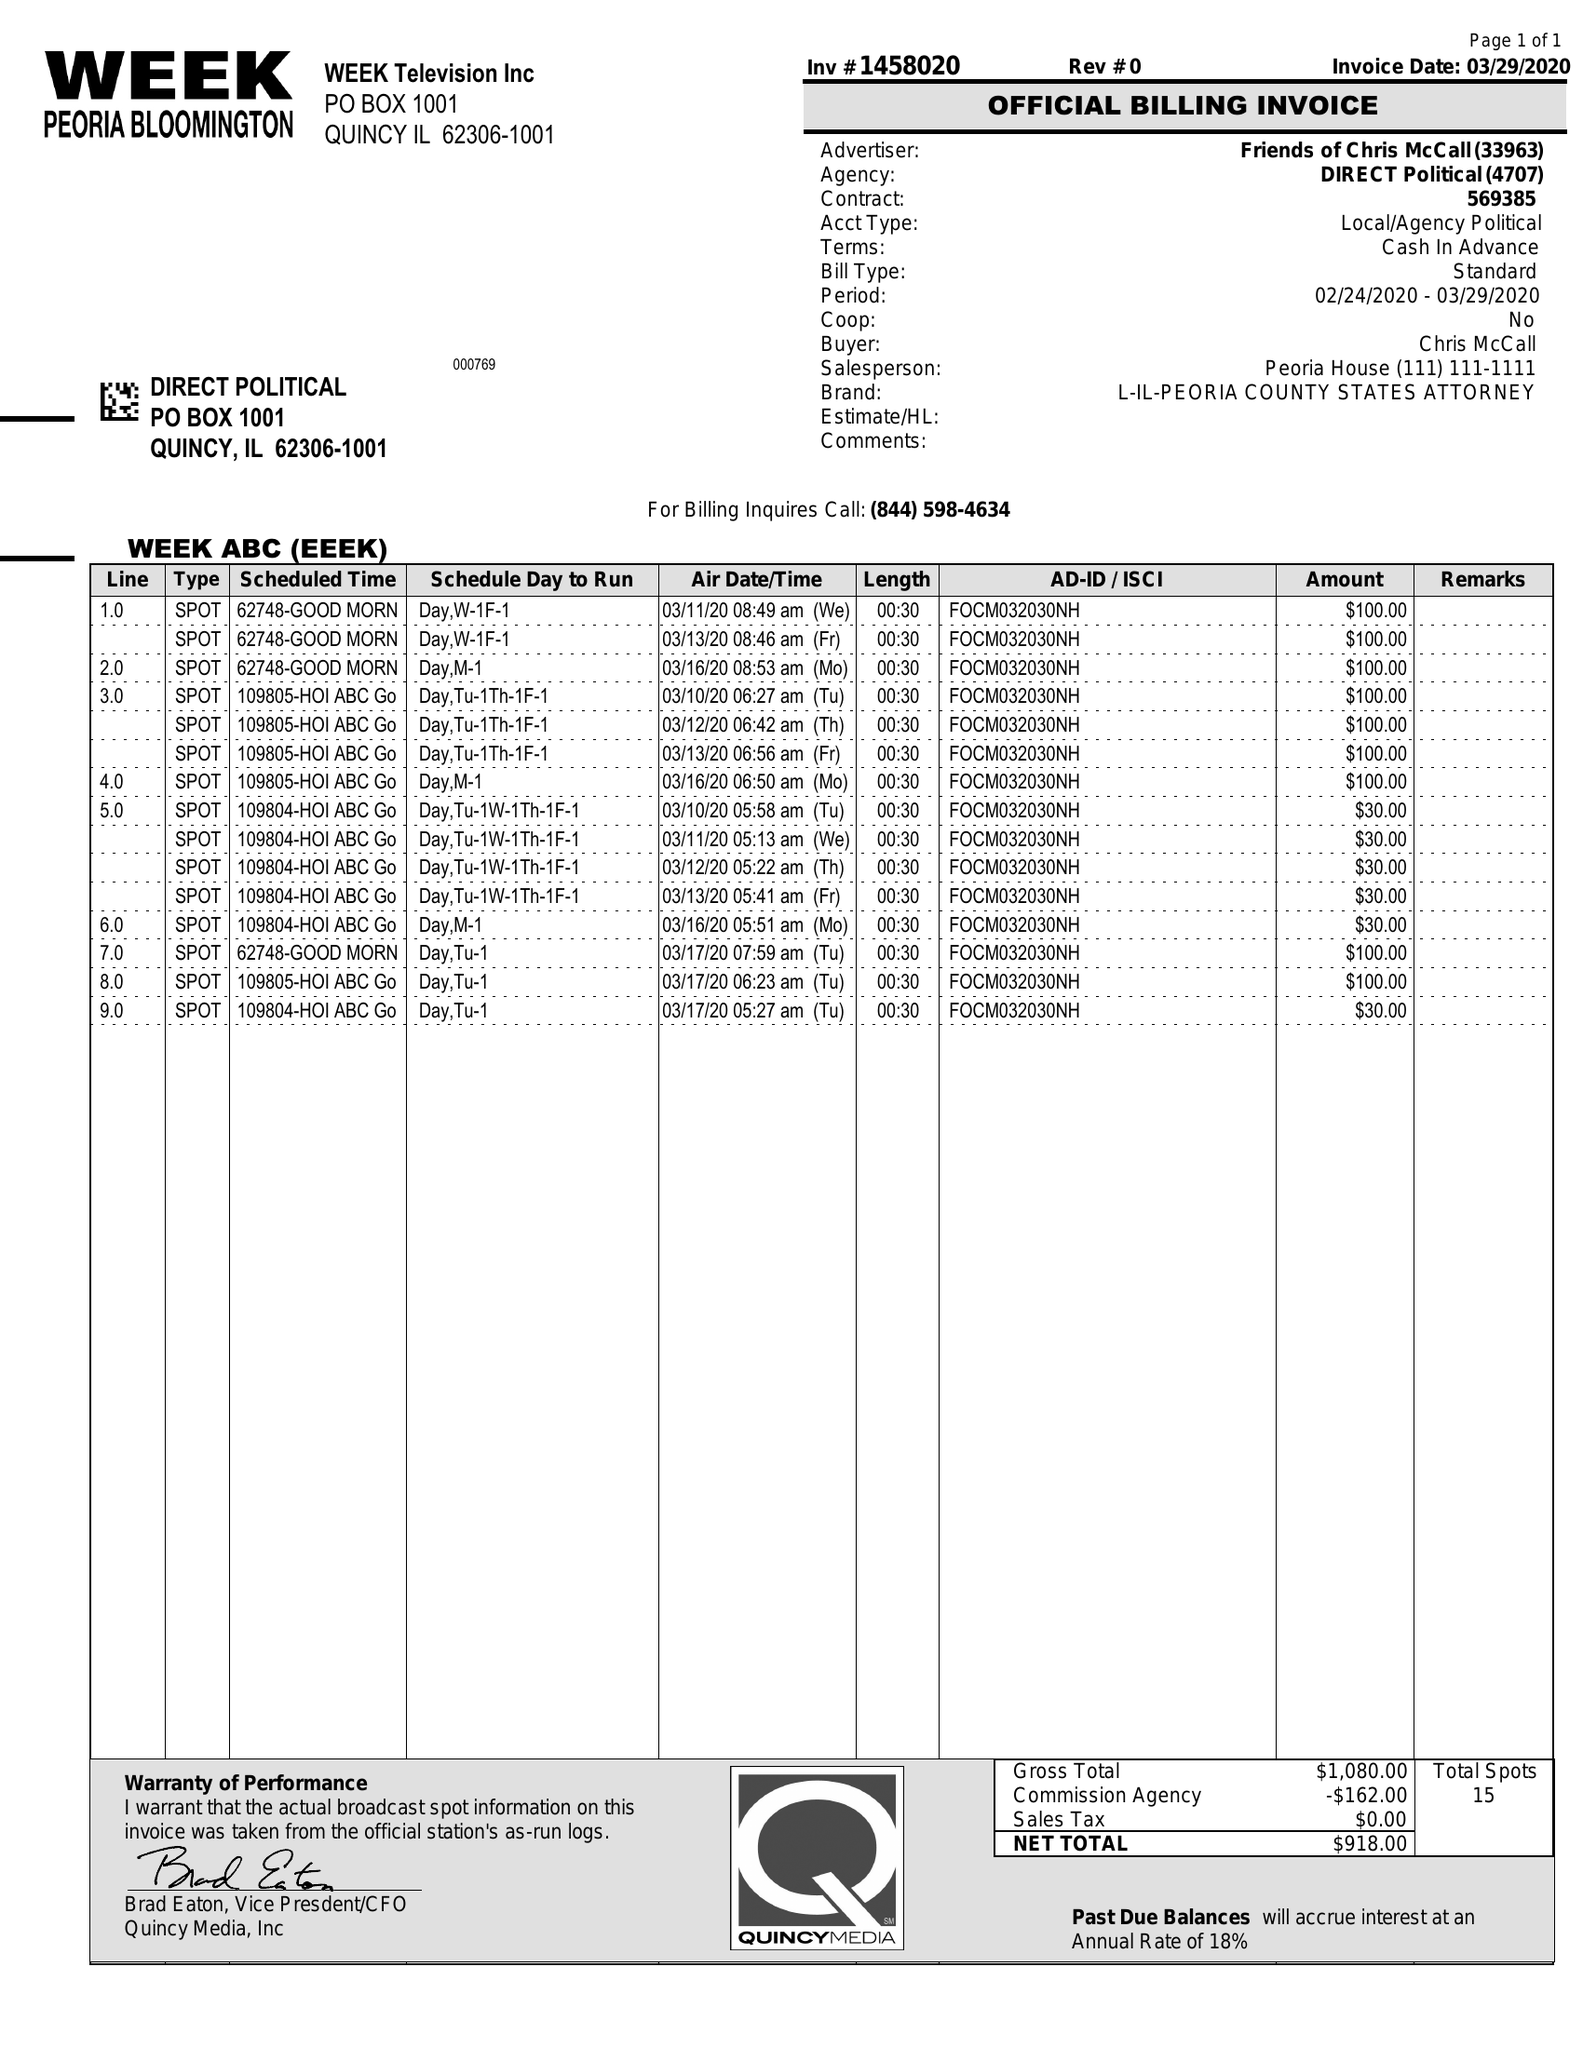What is the value for the flight_to?
Answer the question using a single word or phrase. 03/17/20 